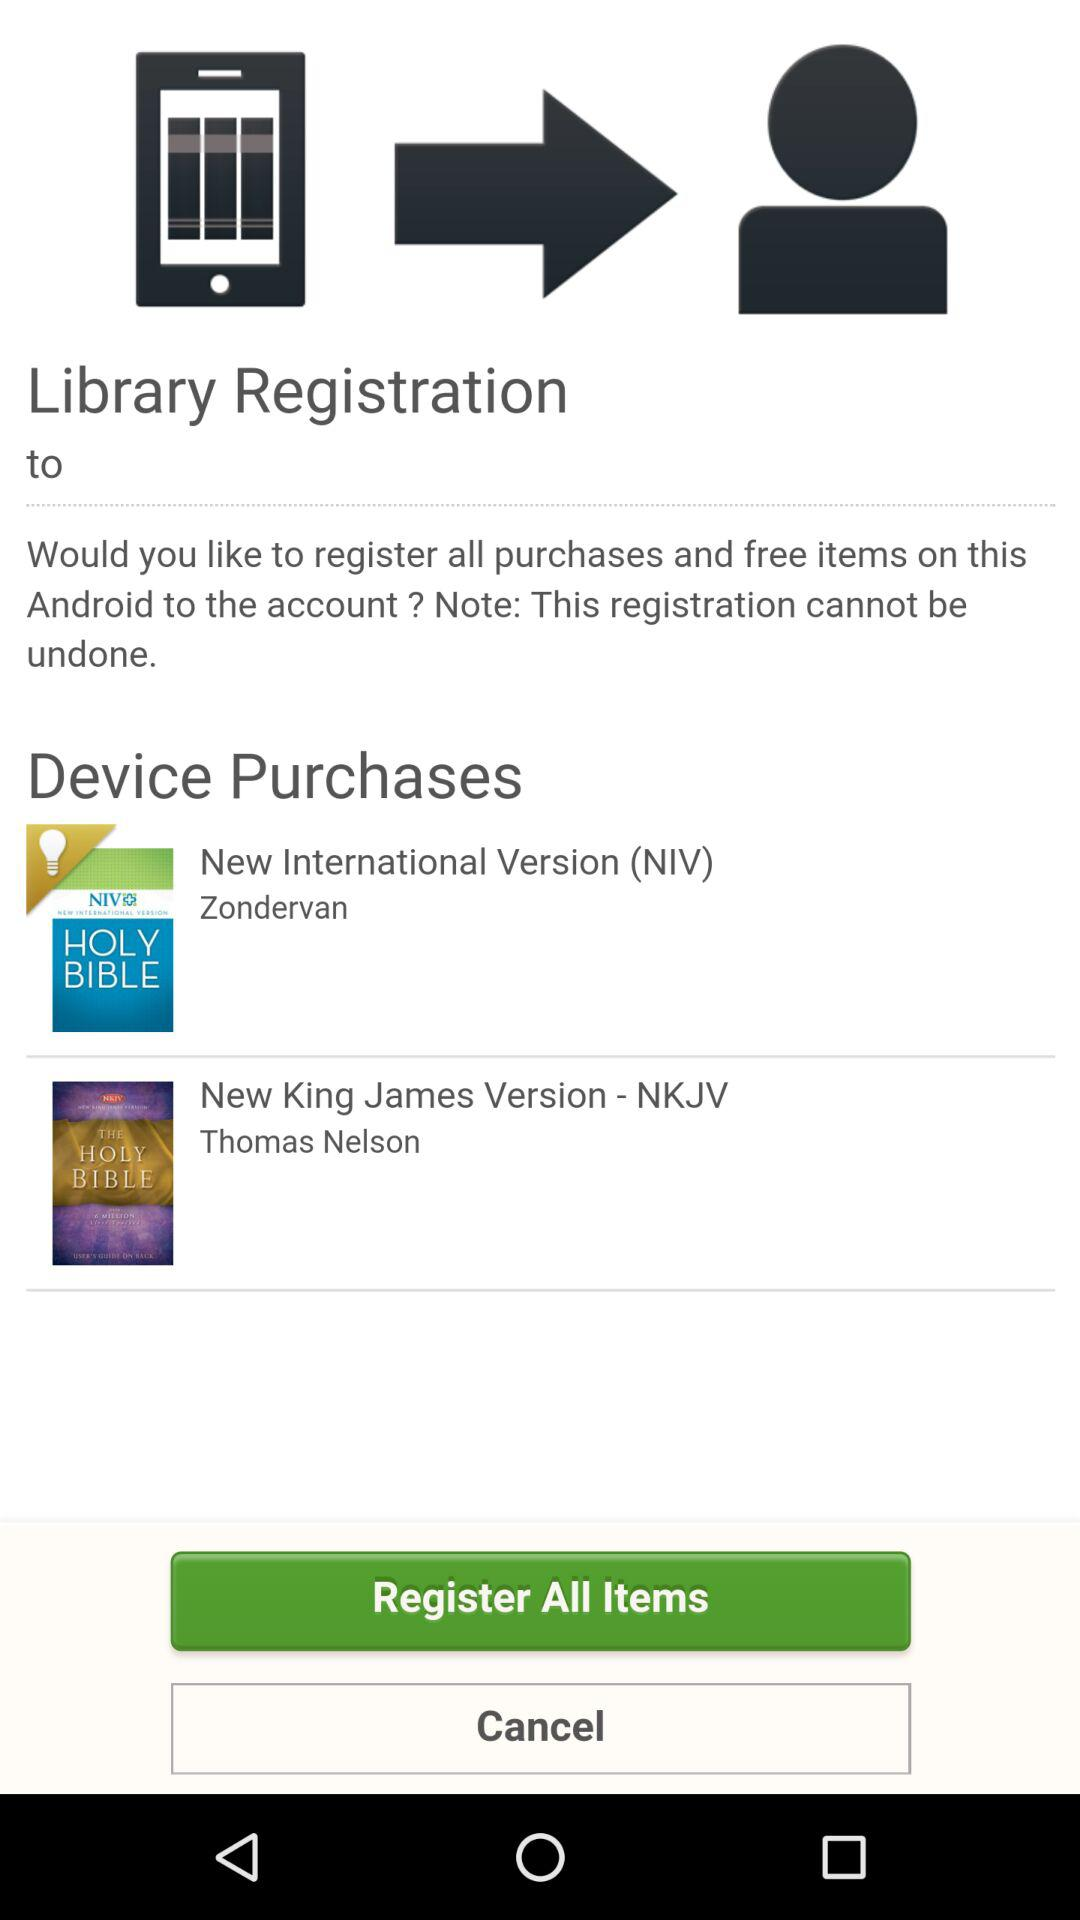What are the options available for "Device Purchases"? The available options are "New International Version (NIV)" and "New King James Version - NKJV". 